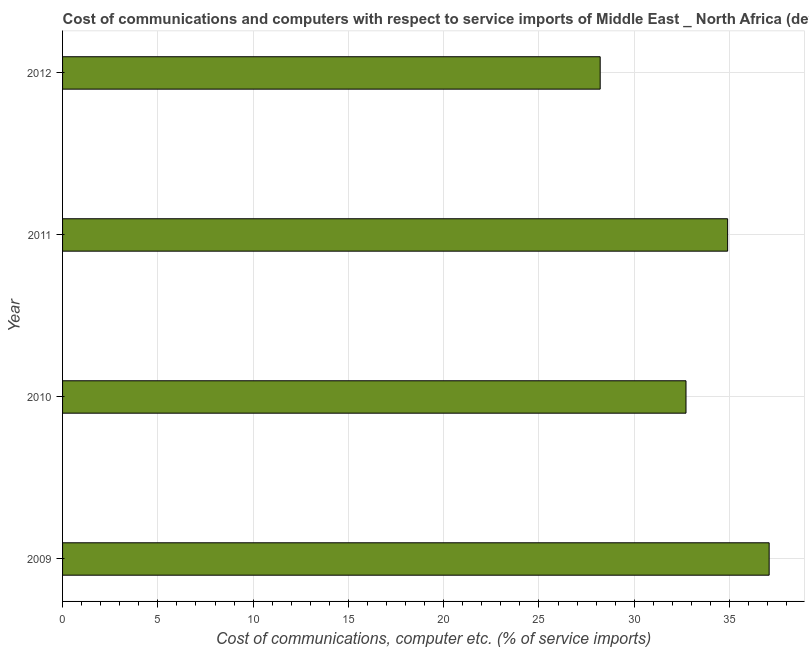Does the graph contain any zero values?
Offer a terse response. No. What is the title of the graph?
Your response must be concise. Cost of communications and computers with respect to service imports of Middle East _ North Africa (developing only). What is the label or title of the X-axis?
Your response must be concise. Cost of communications, computer etc. (% of service imports). What is the cost of communications and computer in 2009?
Offer a very short reply. 37.08. Across all years, what is the maximum cost of communications and computer?
Offer a very short reply. 37.08. Across all years, what is the minimum cost of communications and computer?
Provide a short and direct response. 28.21. What is the sum of the cost of communications and computer?
Offer a very short reply. 132.91. What is the difference between the cost of communications and computer in 2010 and 2012?
Ensure brevity in your answer.  4.5. What is the average cost of communications and computer per year?
Offer a very short reply. 33.23. What is the median cost of communications and computer?
Keep it short and to the point. 33.81. In how many years, is the cost of communications and computer greater than 6 %?
Keep it short and to the point. 4. What is the ratio of the cost of communications and computer in 2010 to that in 2011?
Give a very brief answer. 0.94. Is the cost of communications and computer in 2009 less than that in 2012?
Your response must be concise. No. What is the difference between the highest and the second highest cost of communications and computer?
Your answer should be compact. 2.18. What is the difference between the highest and the lowest cost of communications and computer?
Provide a short and direct response. 8.87. In how many years, is the cost of communications and computer greater than the average cost of communications and computer taken over all years?
Offer a very short reply. 2. How many bars are there?
Ensure brevity in your answer.  4. What is the difference between two consecutive major ticks on the X-axis?
Give a very brief answer. 5. What is the Cost of communications, computer etc. (% of service imports) of 2009?
Your response must be concise. 37.08. What is the Cost of communications, computer etc. (% of service imports) in 2010?
Your answer should be compact. 32.72. What is the Cost of communications, computer etc. (% of service imports) in 2011?
Your answer should be very brief. 34.9. What is the Cost of communications, computer etc. (% of service imports) in 2012?
Provide a succinct answer. 28.21. What is the difference between the Cost of communications, computer etc. (% of service imports) in 2009 and 2010?
Provide a short and direct response. 4.36. What is the difference between the Cost of communications, computer etc. (% of service imports) in 2009 and 2011?
Make the answer very short. 2.18. What is the difference between the Cost of communications, computer etc. (% of service imports) in 2009 and 2012?
Keep it short and to the point. 8.87. What is the difference between the Cost of communications, computer etc. (% of service imports) in 2010 and 2011?
Provide a short and direct response. -2.18. What is the difference between the Cost of communications, computer etc. (% of service imports) in 2010 and 2012?
Your response must be concise. 4.5. What is the difference between the Cost of communications, computer etc. (% of service imports) in 2011 and 2012?
Provide a short and direct response. 6.69. What is the ratio of the Cost of communications, computer etc. (% of service imports) in 2009 to that in 2010?
Offer a terse response. 1.13. What is the ratio of the Cost of communications, computer etc. (% of service imports) in 2009 to that in 2011?
Your response must be concise. 1.06. What is the ratio of the Cost of communications, computer etc. (% of service imports) in 2009 to that in 2012?
Give a very brief answer. 1.31. What is the ratio of the Cost of communications, computer etc. (% of service imports) in 2010 to that in 2011?
Give a very brief answer. 0.94. What is the ratio of the Cost of communications, computer etc. (% of service imports) in 2010 to that in 2012?
Your answer should be very brief. 1.16. What is the ratio of the Cost of communications, computer etc. (% of service imports) in 2011 to that in 2012?
Keep it short and to the point. 1.24. 